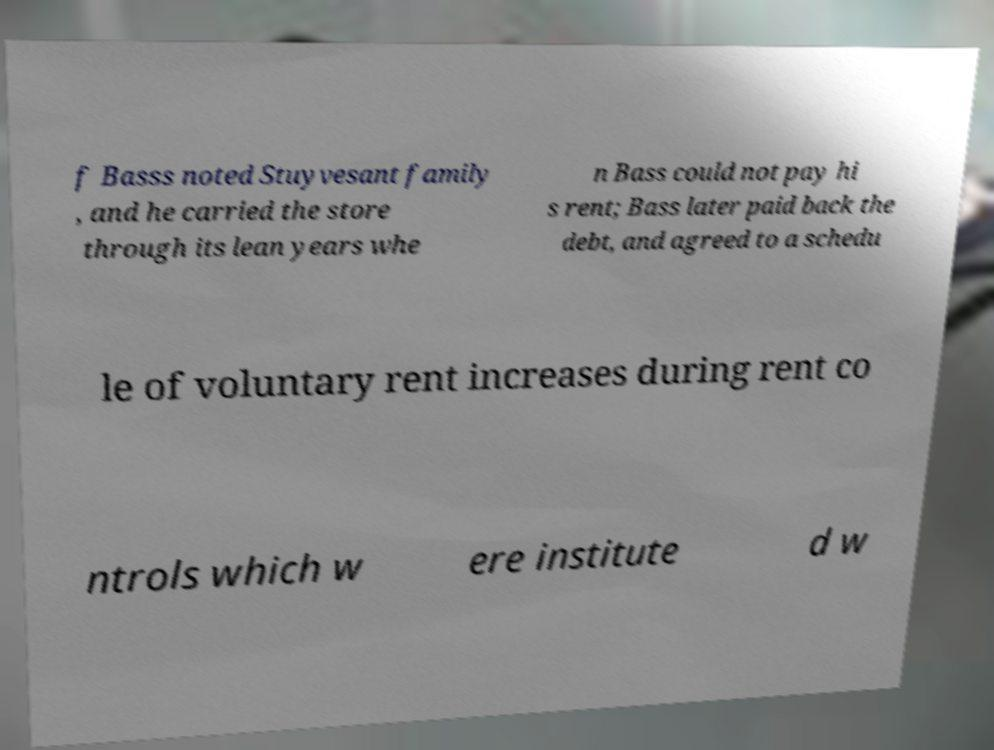Could you assist in decoding the text presented in this image and type it out clearly? f Basss noted Stuyvesant family , and he carried the store through its lean years whe n Bass could not pay hi s rent; Bass later paid back the debt, and agreed to a schedu le of voluntary rent increases during rent co ntrols which w ere institute d w 